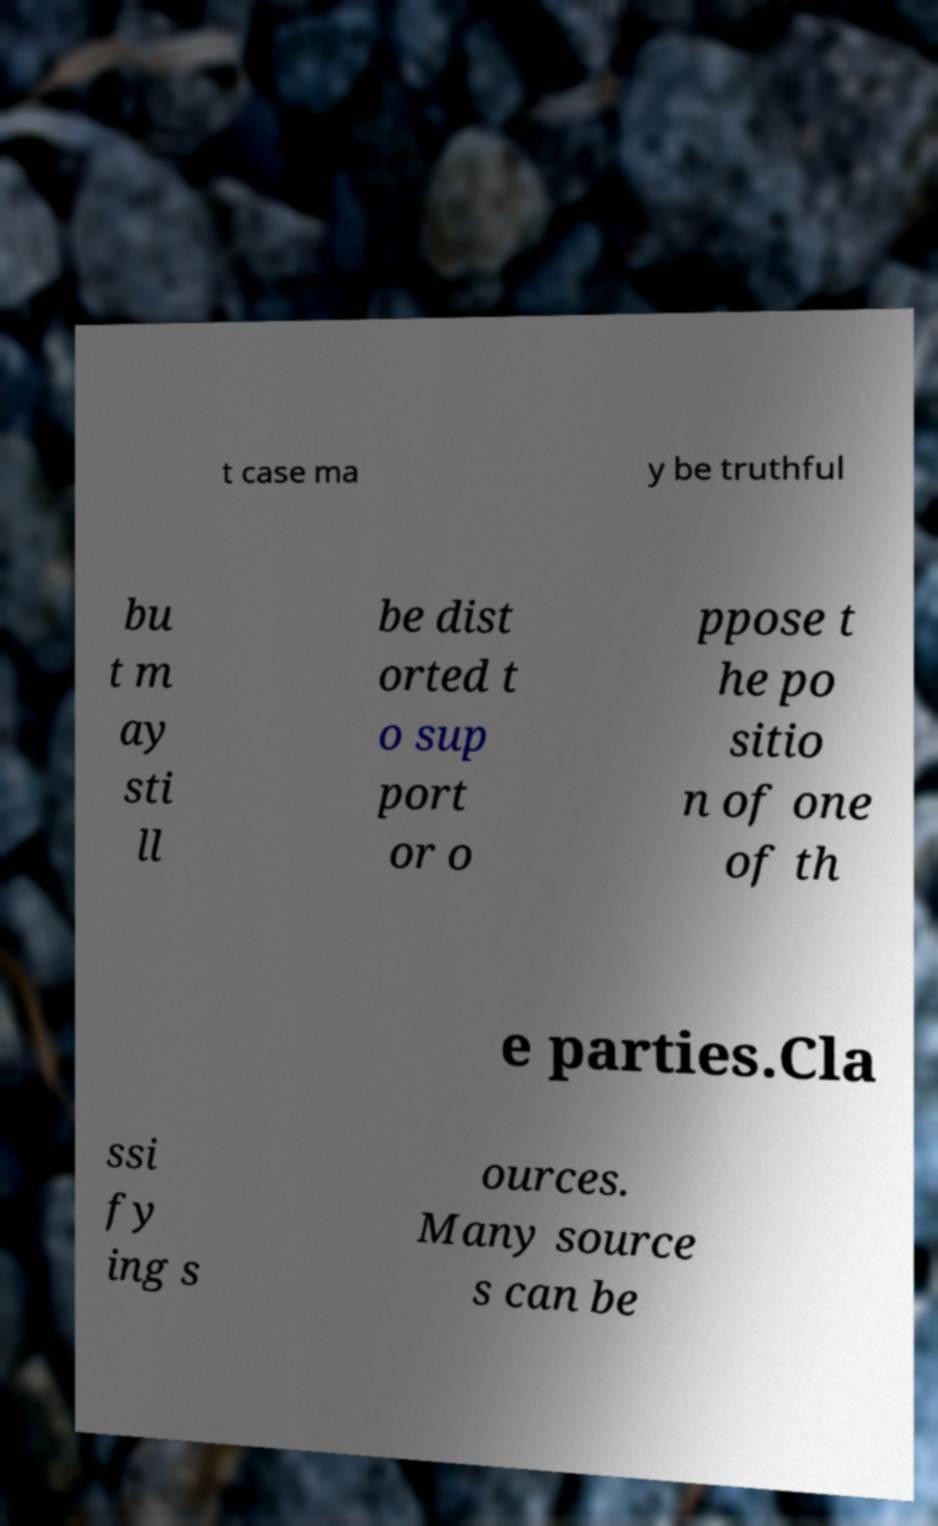I need the written content from this picture converted into text. Can you do that? t case ma y be truthful bu t m ay sti ll be dist orted t o sup port or o ppose t he po sitio n of one of th e parties.Cla ssi fy ing s ources. Many source s can be 